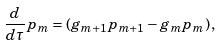Convert formula to latex. <formula><loc_0><loc_0><loc_500><loc_500>\frac { d } { d \tau } p _ { m } = ( g _ { m + 1 } p _ { m + 1 } - g _ { m } p _ { m } ) \, ,</formula> 